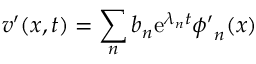Convert formula to latex. <formula><loc_0><loc_0><loc_500><loc_500>v ^ { \prime } ( x , t ) = \sum _ { n } b _ { n } e ^ { \lambda _ { n } t } \phi ^ { \prime } _ { n } ( x )</formula> 